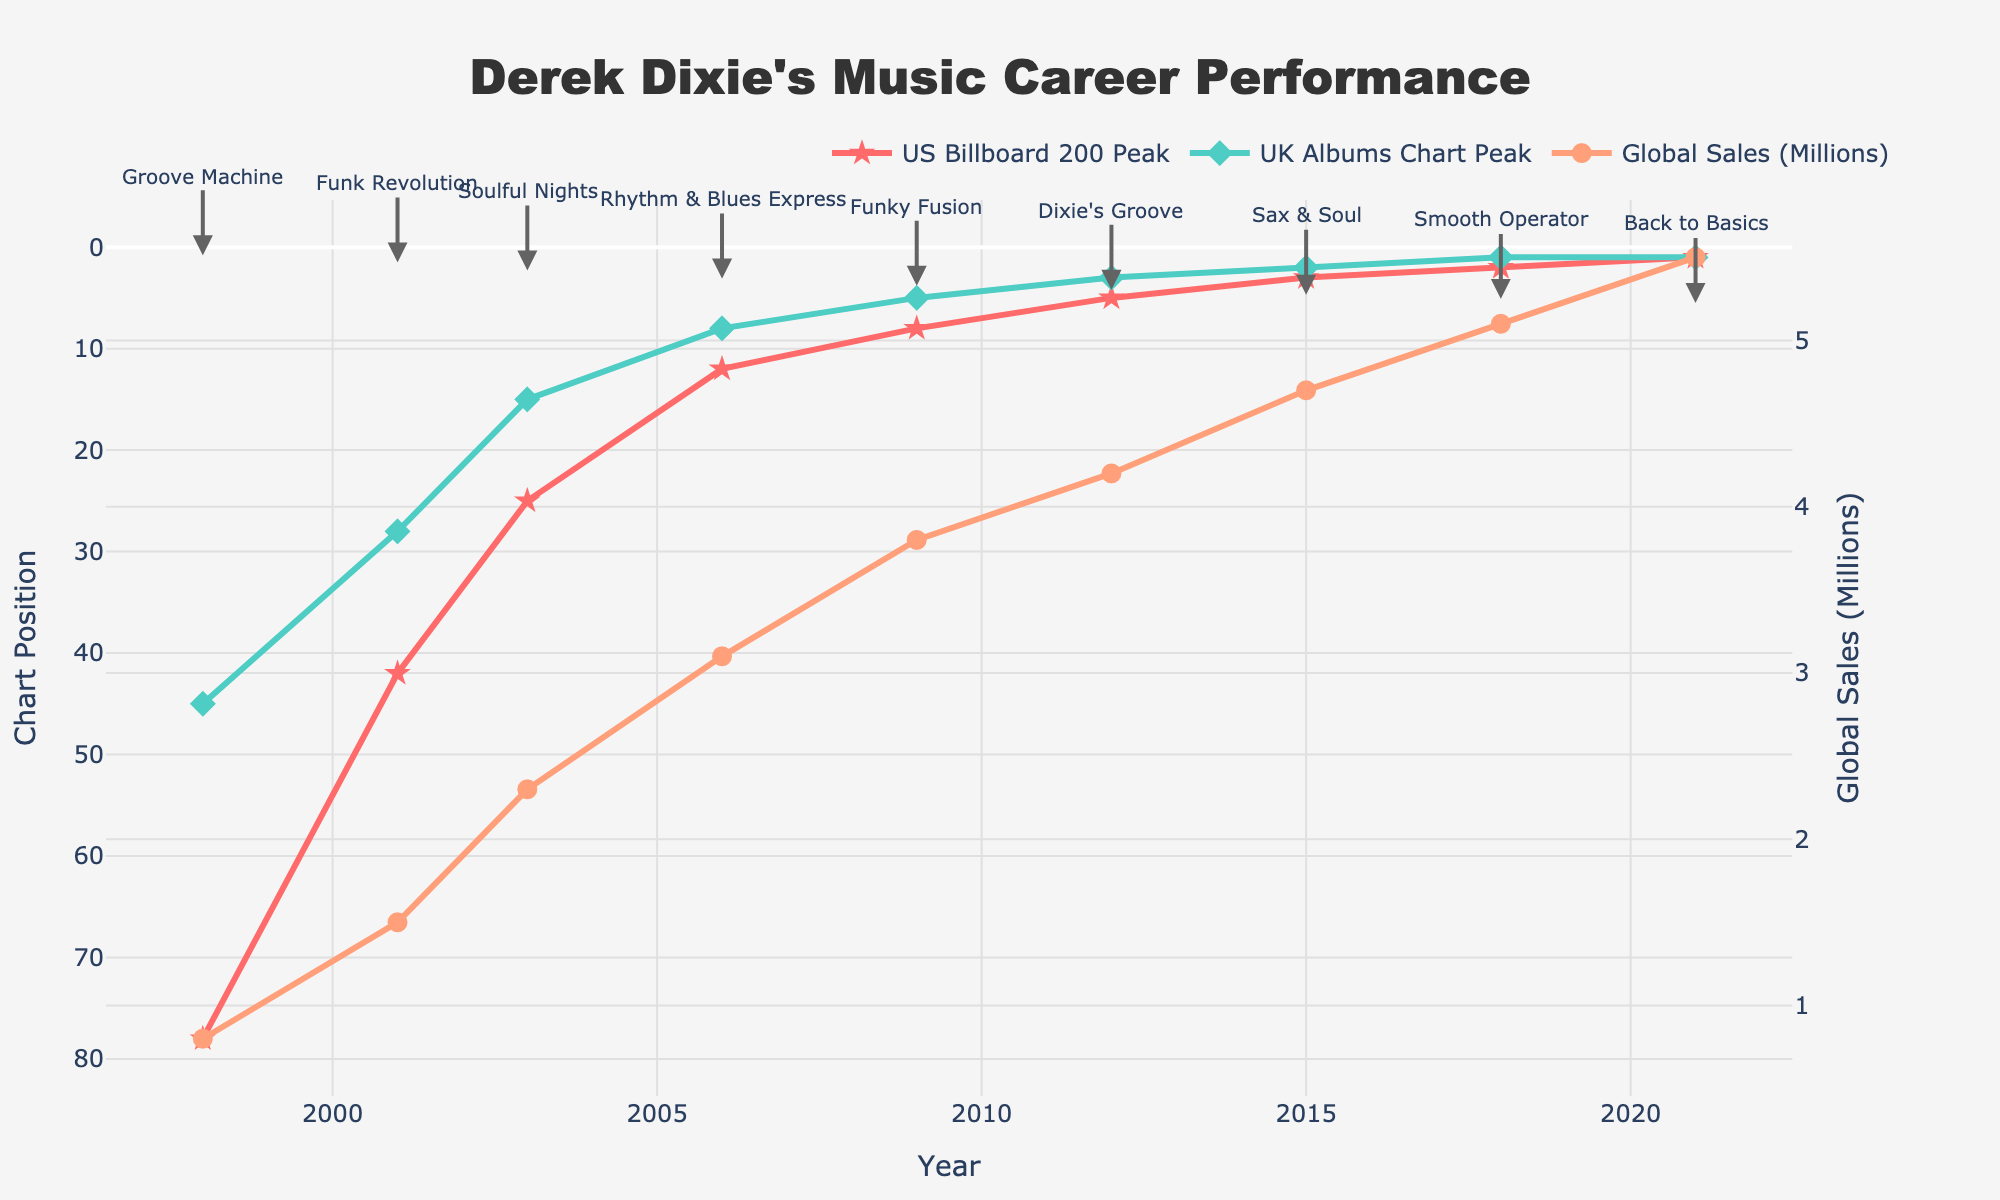Which album had the highest peak on the US Billboard 200? Look for the album with the lowest numerical value on the "US Billboard 200 Peak" line. The chart with the lowest peak is at "1", which corresponds to the album "Back to Basics".
Answer: "Back to Basics" During which year did Derek Dixie have his first album appear on the UK Albums Chart? Trace the "UK Albums Chart Peak" line to find the first occurrence. The first data point appears in 1998, corresponding to "Groove Machine".
Answer: 1998 What is the difference in global sales between "Dixie's Groove" and "Smooth Operator"? Find the "Global Sales (Millions)" values for both albums. "Dixie's Groove" has 4.2 million and "Smooth Operator" has 5.1 million. The difference is 5.1 - 4.2 = 0.9 million.
Answer: 0.9 million Which album has both the highest global sales and the highest peak on the UK Albums Chart? Examine the peaks of each line and find the album that appears at the top of both. "Back to Basics" has 5.5 million sales and a peak position of 1 on the UK Albums Chart.
Answer: "Back to Basics" How much did the global sales increase from "Rhythm & Blues Express" to "Funky Fusion"? "Rhythm & Blues Express" had 3.1 million sales and "Funky Fusion" had 3.8 million sales. The increase is 3.8 - 3.1 = 0.7 million.
Answer: 0.7 million Which album shows the most significant improvement in "US Billboard 200 Peak" position compared to its previous release? Compare the peak positions of each album sequentially. The transition from "Funky Fusion" (position 8) to "Dixie's Groove" (position 5) shows the greatest improvement of 8 - 5 = 3 positions.
Answer: "Dixie's Groove" What is the average global sales for all the albums? Sum all the global sales values: 0.8 + 1.5 + 2.3 + 3.1 + 3.8 + 4.2 + 4.7 + 5.1 + 5.5 = 31 million, then divide by the number of albums: 31 / 9 ≈ 3.44 million.
Answer: 3.44 million Between which two consecutive albums did the peak on the UK Albums Chart improve the most? Look for the largest change in peak positions on the "UK Albums Chart Peak" between consecutive albums. The largest improvement is from "Funky Fusion" (position 5) to "Dixie's Groove" (position 3), an improvement of 2 positions.
Answer: "Funky Fusion" to "Dixie's Groove" 